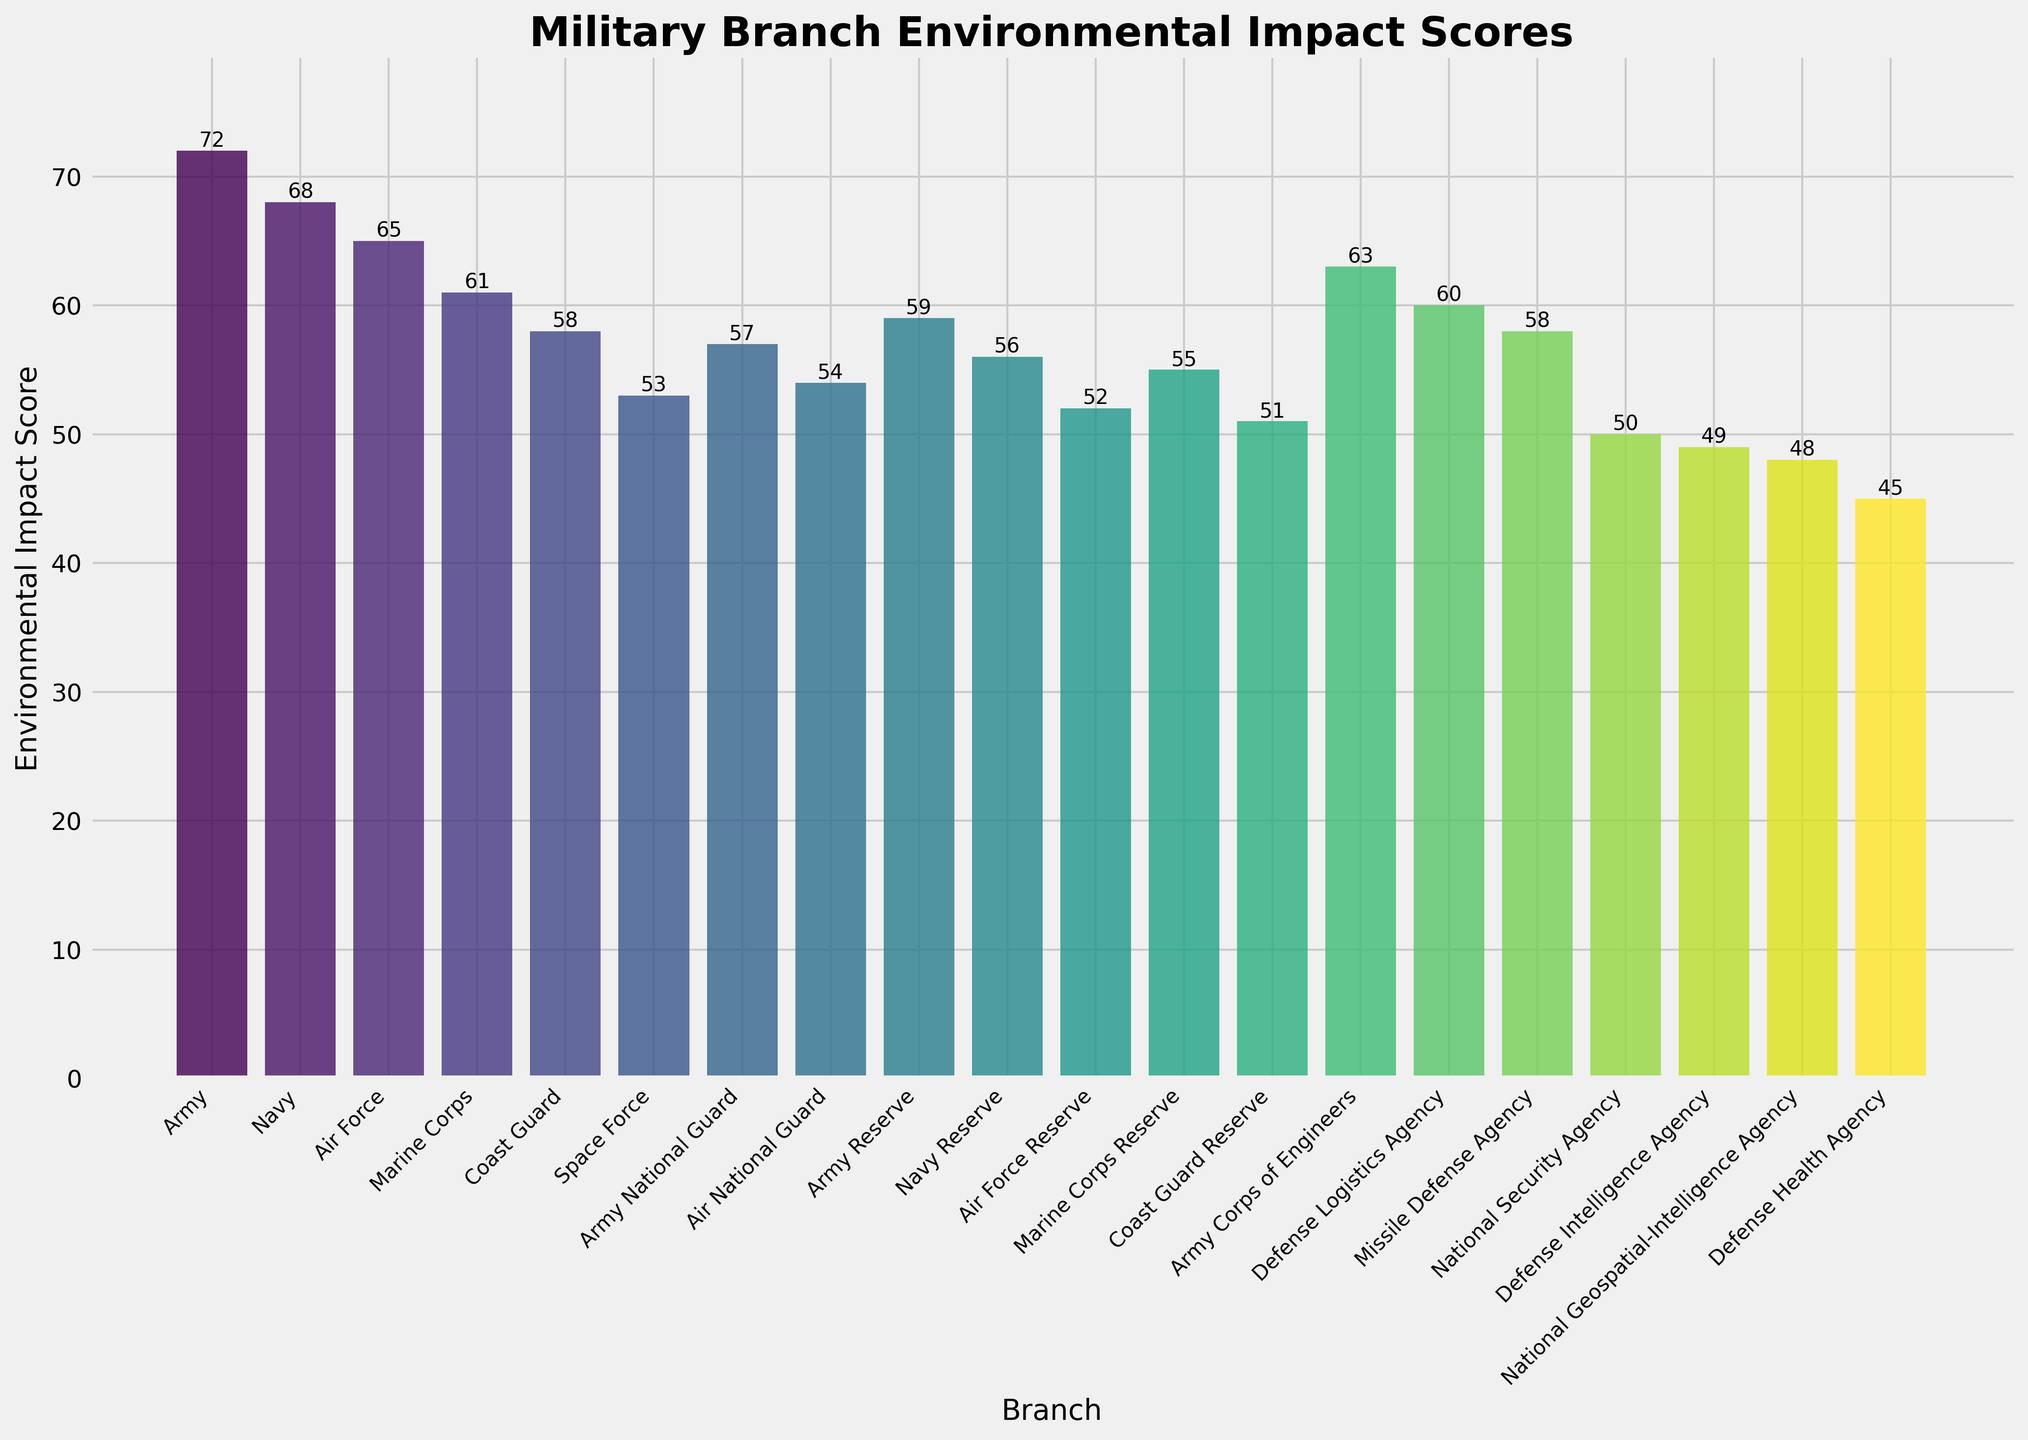What's the highest environmental impact score and which branch does it belong to? The highest bar visually represents the highest score. The Army's bar reaches 72, which is the highest score.
Answer: Army with a score of 72 Which branch has the lowest environmental impact score? The shortest bar denotes the lowest score. The Defense Health Agency has the lowest bar with a score of 45.
Answer: Defense Health Agency with a score of 45 What is the difference in environmental impact scores between the Army and the Air Force? The Army's score is 72 and the Air Force's score is 65. The difference is calculated by subtraction: 72 - 65.
Answer: 7 What is the average environmental impact score of the top three branches with the highest scores? The top three scores are Army (72), Navy (68), and Air Force (65). Sum these scores and divide by 3 to get the average: (72 + 68 + 65) / 3.
Answer: 68.33 Which branch has a higher environmental impact score, the Marine Corps or the Marine Corps Reserve? The bar for the Marine Corps reaches 61, while the Marine Corps Reserve reaches 55. Thus, the Marine Corps has a higher score.
Answer: Marine Corps What is the total environmental impact score for all branches? Sum the scores of all branches: 72, 68, 65, 61, 58, 53, 57, 54, 59, 56, 52, 55, 51, 63, 60, 58, 50, 49, 48, and 45.
Answer: 1034 Does the Coast Guard Reserve have a higher or lower environmental impact score compared to the Air National Guard? Coast Guard Reserve's score is 51 and the Air National Guard's score is 54. Thus, it is lower.
Answer: Lower What’s the combined score of the Army National Guard and the Air National Guard? Adding their scores: Army National Guard (57) and Air National Guard (54), the combined score is 57 + 54.
Answer: 111 Which branch has the closest environmental impact score to the Coast Guard? The Coast Guard's score is 58. The Missile Defense Agency also has a score of 58, making them equal.
Answer: Missile Defense Agency 